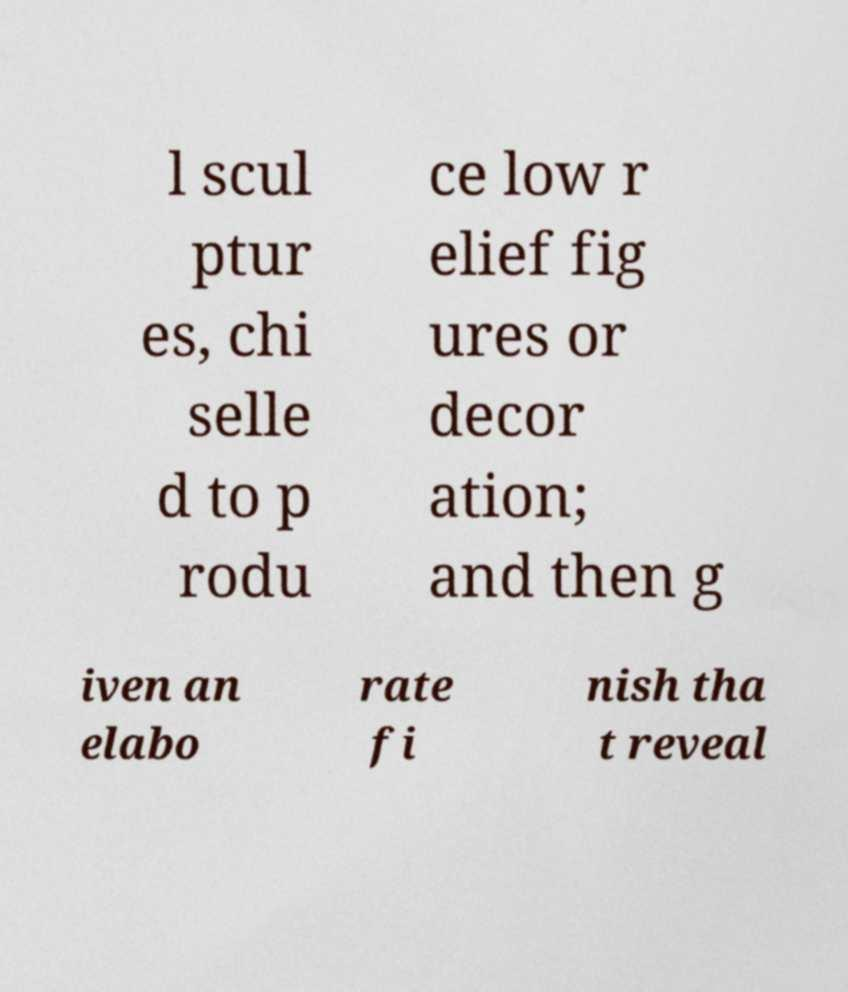Please read and relay the text visible in this image. What does it say? l scul ptur es, chi selle d to p rodu ce low r elief fig ures or decor ation; and then g iven an elabo rate fi nish tha t reveal 